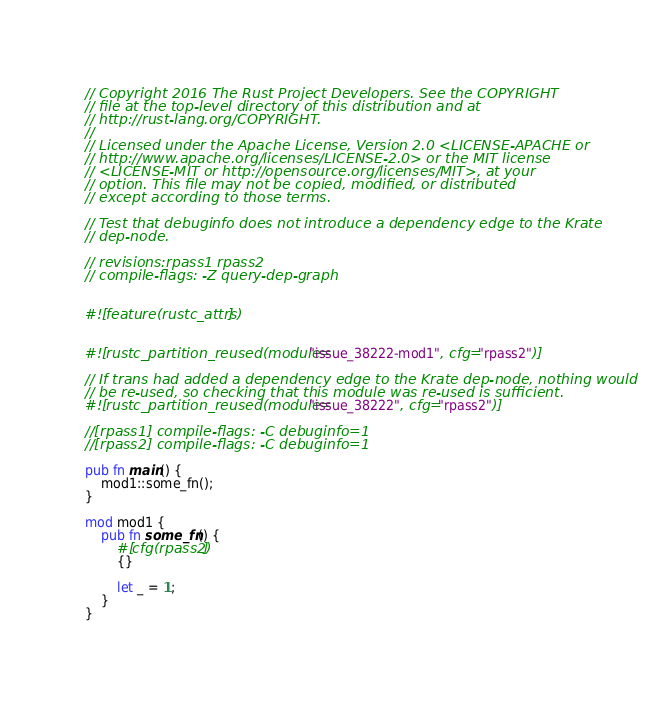<code> <loc_0><loc_0><loc_500><loc_500><_Rust_>// Copyright 2016 The Rust Project Developers. See the COPYRIGHT
// file at the top-level directory of this distribution and at
// http://rust-lang.org/COPYRIGHT.
//
// Licensed under the Apache License, Version 2.0 <LICENSE-APACHE or
// http://www.apache.org/licenses/LICENSE-2.0> or the MIT license
// <LICENSE-MIT or http://opensource.org/licenses/MIT>, at your
// option. This file may not be copied, modified, or distributed
// except according to those terms.

// Test that debuginfo does not introduce a dependency edge to the Krate
// dep-node.

// revisions:rpass1 rpass2
// compile-flags: -Z query-dep-graph


#![feature(rustc_attrs)]


#![rustc_partition_reused(module="issue_38222-mod1", cfg="rpass2")]

// If trans had added a dependency edge to the Krate dep-node, nothing would
// be re-used, so checking that this module was re-used is sufficient.
#![rustc_partition_reused(module="issue_38222", cfg="rpass2")]

//[rpass1] compile-flags: -C debuginfo=1
//[rpass2] compile-flags: -C debuginfo=1

pub fn main() {
    mod1::some_fn();
}

mod mod1 {
    pub fn some_fn() {
        #[cfg(rpass2)]
        {}

        let _ = 1;
    }
}
</code> 